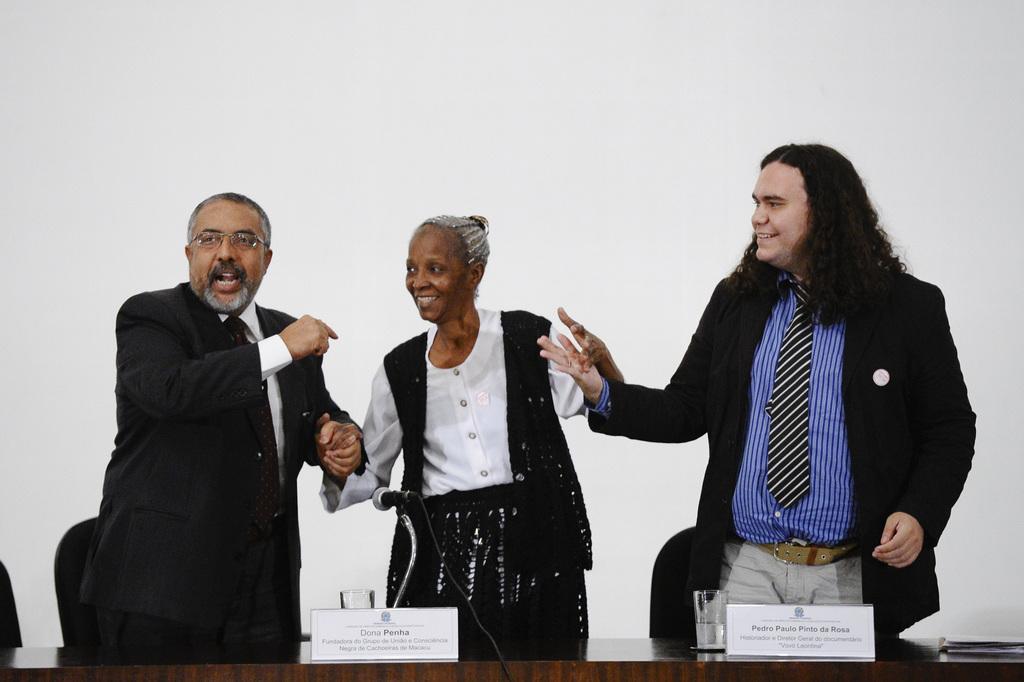In one or two sentences, can you explain what this image depicts? In this image we can see persons standing at the table. At the bottom we can see a table, mic, glass and board. In the background there is a wall and chair. 